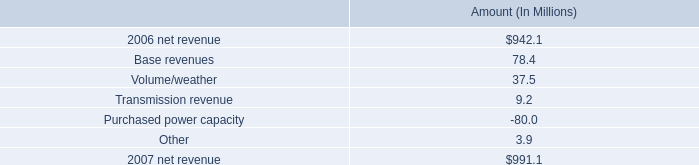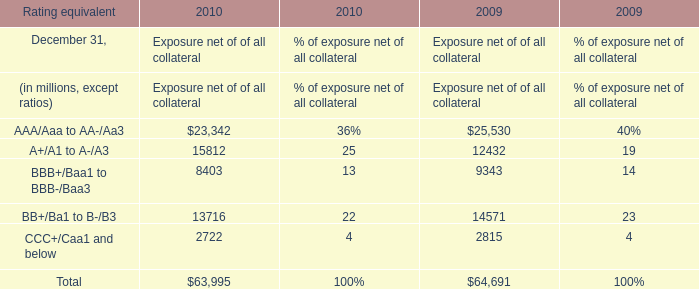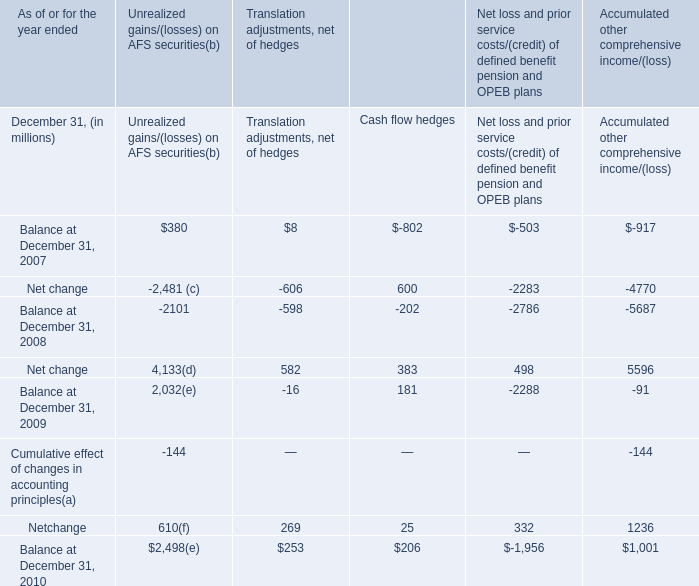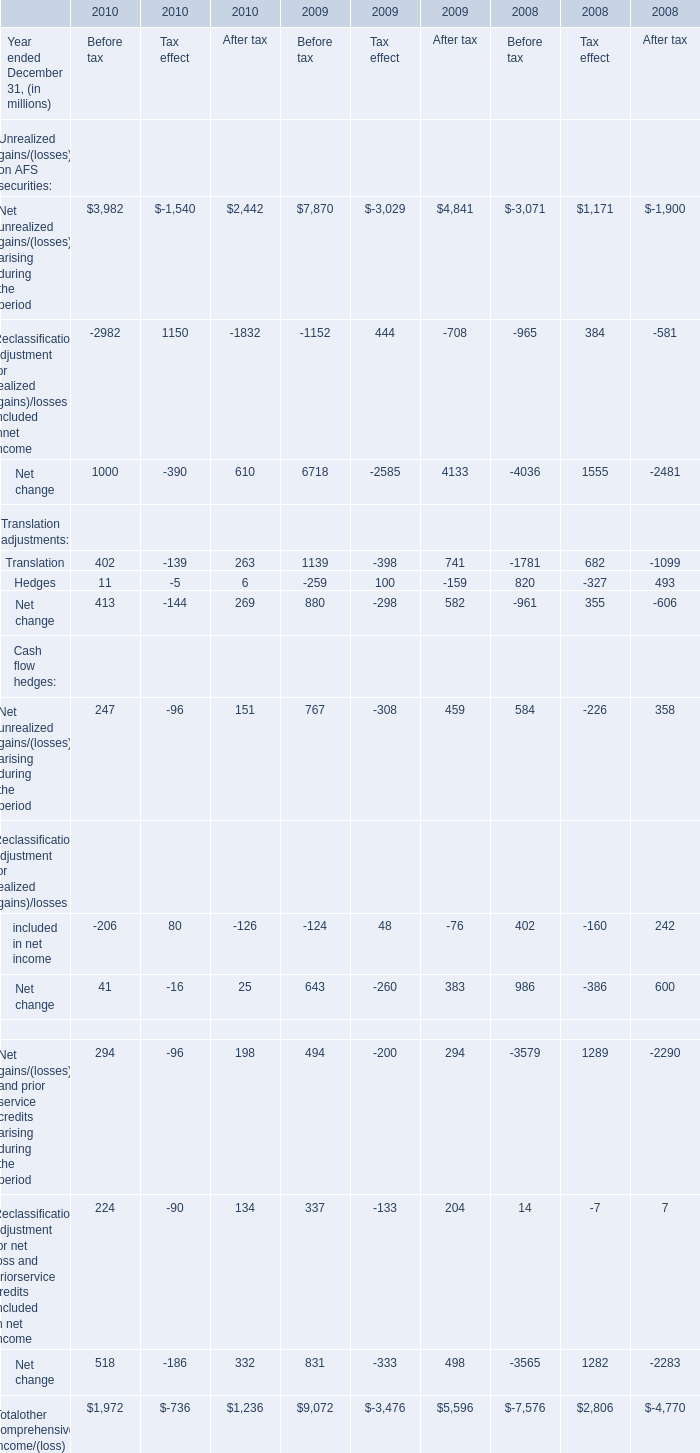what percent of the net change in revenue between 2007 and 2008 was due to volume/weather? 
Computations: (37.5 / (991.1 - 942.1))
Answer: 0.76531. 